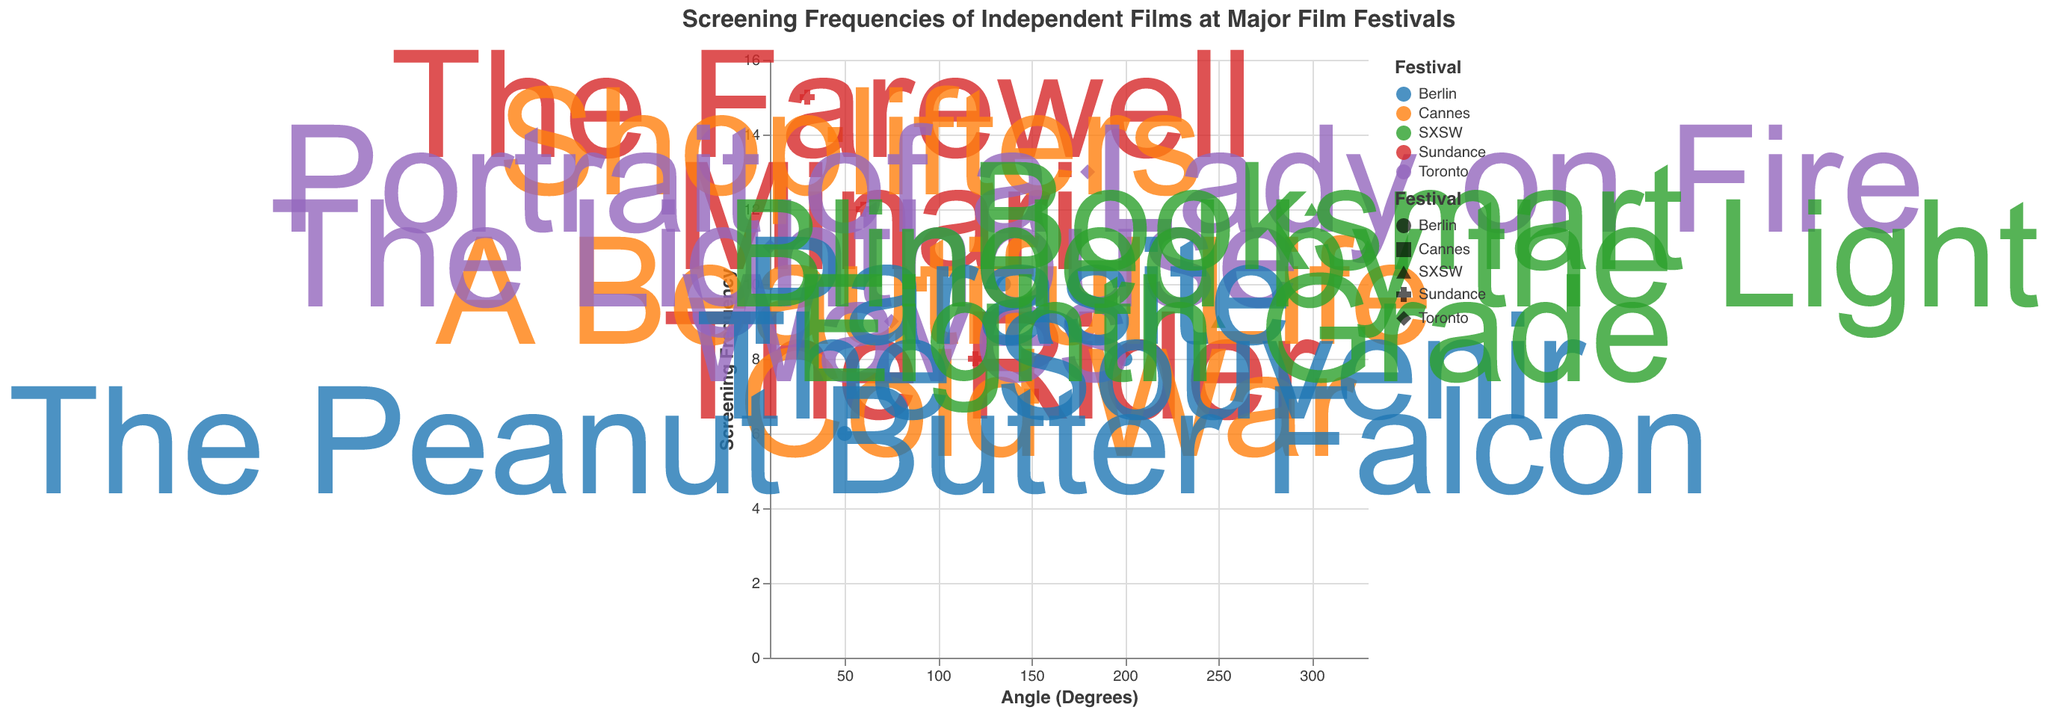What is the title of the polar scatter chart? The title of the chart is written at the top of the figure.
Answer: Screening Frequencies of Independent Films at Major Film Festivals Which film has the highest screening frequency at the Sundance Film Festival? By looking at the points representing Sundance films, "The Farewell" has a screening frequency of 15, the highest among Sundance films.
Answer: The Farewell How many festivals are represented in the chart? Each distinct color in the chart represents a different festival. By counting the distinct colors, we see there are five festivals: Sundance, Cannes, Toronto, Berlin, and SXSW.
Answer: 5 Which film is screened the most frequently among all festivals? By looking at the data points with the highest values, "The Farewell" has the highest screening frequency of 15.
Answer: The Farewell What is the average screening frequency of films at the Toronto Film Festival? Calculate the average screening frequency by summing all frequencies of Toronto films (11 + 9 + 13) = 33 and then dividing by the number of films (3).
Answer: 11 Which film at the SXSW festival has the lowest screening frequency? The films at SXSW are "Booksmart" (12), "Eighth Grade" (9), and "Blinded by the Light" (11). "Eighth Grade" has the lowest screening frequency.
Answer: Eighth Grade What is the difference in screening frequency between "The Lighthouse" at the Toronto Film Festival and "A Beautiful Life" at the Cannes Film Festival? "The Lighthouse" has a frequency of 11, and "A Beautiful Life" has a frequency of 10. The difference is 11 - 10 = 1.
Answer: 1 Compare the screening frequency of "Minari" at Sundance and "Parasite" at Berlin. Which one is higher? "Minari" has a screening frequency of 12, and "Parasite" has a frequency of 10, so "Minari" is higher.
Answer: Minari How many films have a screening frequency greater than 10? Count the points with screening frequencies above 10: "The Farewell" (15), "Minari" (12), "Shoplifters" (14), "Portrait of a Lady on Fire" (13), "Booksmart" (12), and "Blinded by the Light" (11). There are six films.
Answer: 6 What is the total screening frequency for films at the Cannes Film Festival? Sum the frequencies for Cannes films: 10 (A Beautiful Life) + 7 (Cold War) + 14 (Shoplifters) = 31.
Answer: 31 